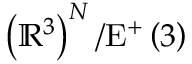Convert formula to latex. <formula><loc_0><loc_0><loc_500><loc_500>\left ( \mathbb { R } ^ { 3 } \right ) ^ { N } / E ^ { + } \left ( 3 \right )</formula> 